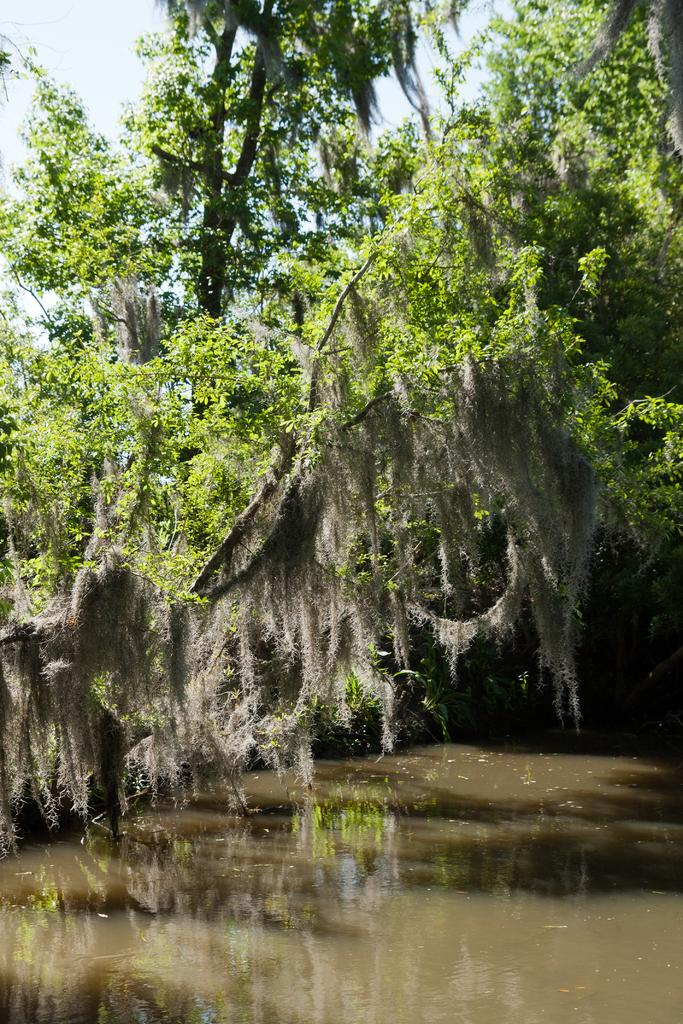What type of natural feature is present in the image? There is a river in the image. Can you describe the condition of the river? The river appears to be dirty. What type of vegetation is near the river? There are trees near the river. What type of harmony can be heard coming from the river in the image? There is no indication of any sound, let alone harmony, in the image. 